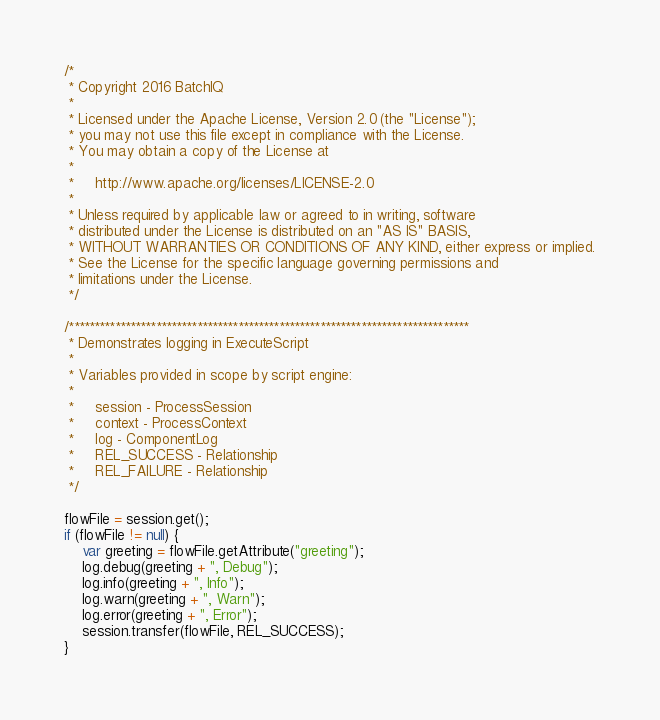Convert code to text. <code><loc_0><loc_0><loc_500><loc_500><_JavaScript_>/*
 * Copyright 2016 BatchIQ
 *
 * Licensed under the Apache License, Version 2.0 (the "License");
 * you may not use this file except in compliance with the License.
 * You may obtain a copy of the License at
 *
 *     http://www.apache.org/licenses/LICENSE-2.0
 *
 * Unless required by applicable law or agreed to in writing, software
 * distributed under the License is distributed on an "AS IS" BASIS,
 * WITHOUT WARRANTIES OR CONDITIONS OF ANY KIND, either express or implied.
 * See the License for the specific language governing permissions and
 * limitations under the License.
 */

/******************************************************************************
 * Demonstrates logging in ExecuteScript
 *
 * Variables provided in scope by script engine:
 *
 *     session - ProcessSession
 *     context - ProcessContext
 *     log - ComponentLog
 *     REL_SUCCESS - Relationship
 *     REL_FAILURE - Relationship
 */

flowFile = session.get();
if (flowFile != null) {
    var greeting = flowFile.getAttribute("greeting");
    log.debug(greeting + ", Debug");
    log.info(greeting + ", Info");
    log.warn(greeting + ", Warn");
    log.error(greeting + ", Error");
    session.transfer(flowFile, REL_SUCCESS);
}
</code> 